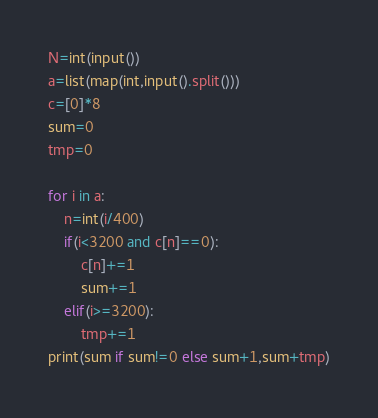<code> <loc_0><loc_0><loc_500><loc_500><_Python_>N=int(input())
a=list(map(int,input().split()))
c=[0]*8
sum=0
tmp=0

for i in a:
    n=int(i/400)
    if(i<3200 and c[n]==0):
        c[n]+=1
        sum+=1
    elif(i>=3200):
        tmp+=1
print(sum if sum!=0 else sum+1,sum+tmp)</code> 